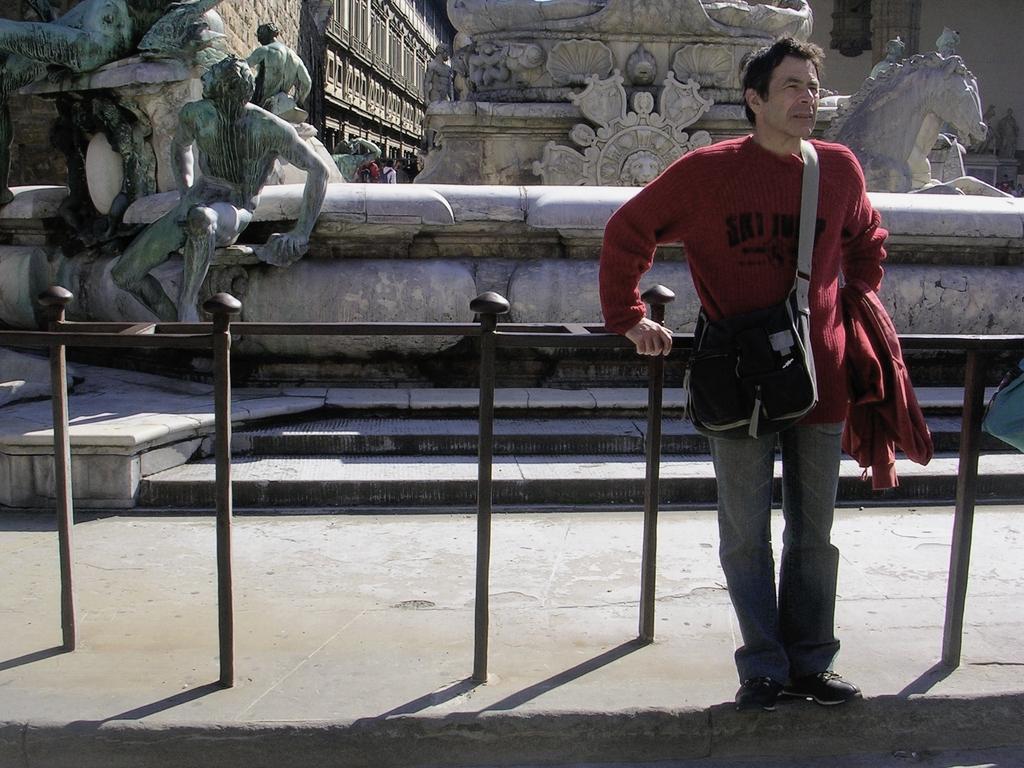Can you describe this image briefly? In the foreground of the image there is a person standing. There is a railing. In the background of the image there are sculptures. At the bottom of the image there is floor. 